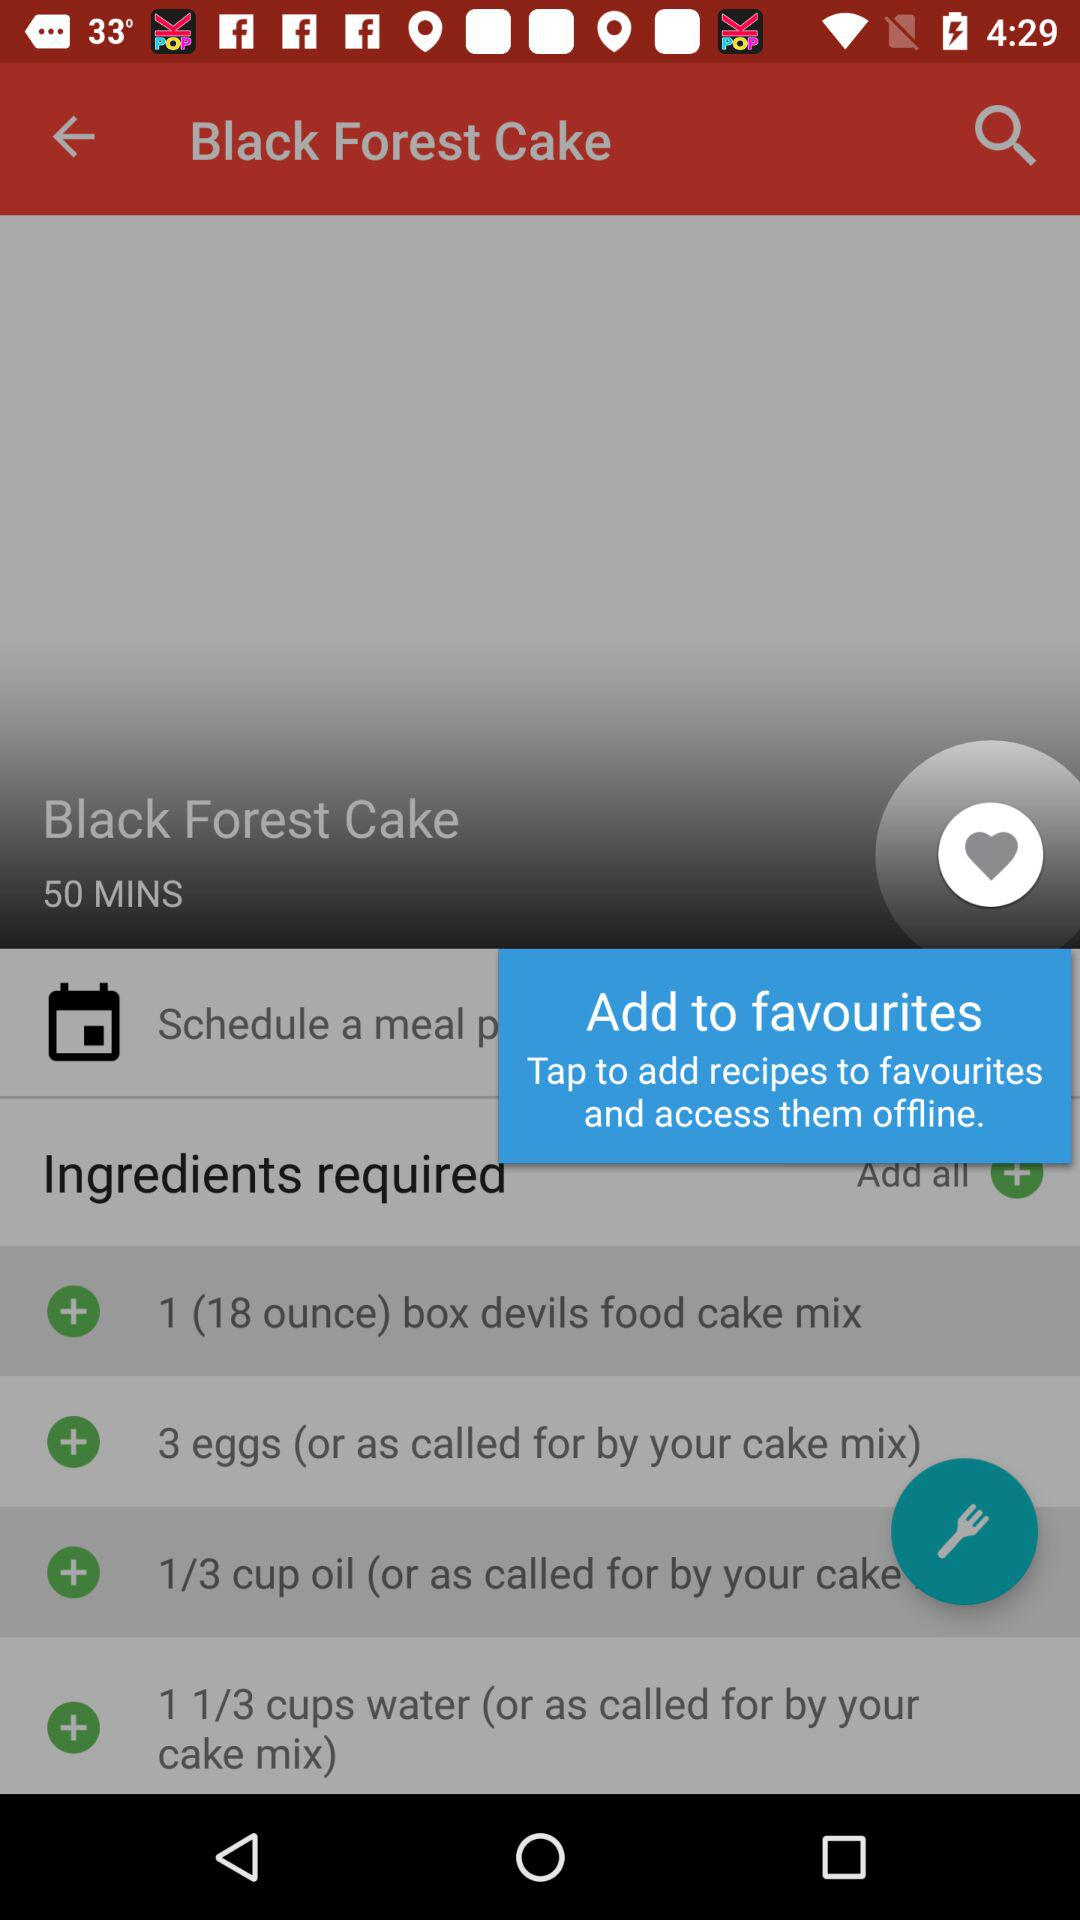How many eggs are required? The required number of eggs is 3. 